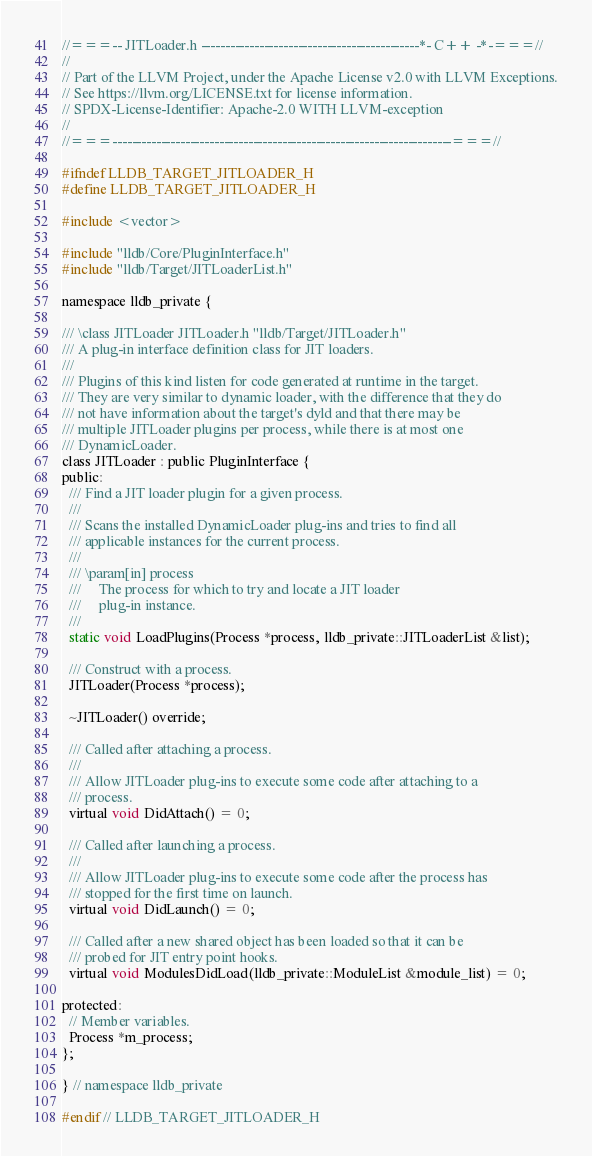<code> <loc_0><loc_0><loc_500><loc_500><_C_>//===-- JITLoader.h ---------------------------------------------*- C++ -*-===//
//
// Part of the LLVM Project, under the Apache License v2.0 with LLVM Exceptions.
// See https://llvm.org/LICENSE.txt for license information.
// SPDX-License-Identifier: Apache-2.0 WITH LLVM-exception
//
//===----------------------------------------------------------------------===//

#ifndef LLDB_TARGET_JITLOADER_H
#define LLDB_TARGET_JITLOADER_H

#include <vector>

#include "lldb/Core/PluginInterface.h"
#include "lldb/Target/JITLoaderList.h"

namespace lldb_private {

/// \class JITLoader JITLoader.h "lldb/Target/JITLoader.h"
/// A plug-in interface definition class for JIT loaders.
///
/// Plugins of this kind listen for code generated at runtime in the target.
/// They are very similar to dynamic loader, with the difference that they do
/// not have information about the target's dyld and that there may be
/// multiple JITLoader plugins per process, while there is at most one
/// DynamicLoader.
class JITLoader : public PluginInterface {
public:
  /// Find a JIT loader plugin for a given process.
  ///
  /// Scans the installed DynamicLoader plug-ins and tries to find all
  /// applicable instances for the current process.
  ///
  /// \param[in] process
  ///     The process for which to try and locate a JIT loader
  ///     plug-in instance.
  ///
  static void LoadPlugins(Process *process, lldb_private::JITLoaderList &list);

  /// Construct with a process.
  JITLoader(Process *process);

  ~JITLoader() override;

  /// Called after attaching a process.
  ///
  /// Allow JITLoader plug-ins to execute some code after attaching to a
  /// process.
  virtual void DidAttach() = 0;

  /// Called after launching a process.
  ///
  /// Allow JITLoader plug-ins to execute some code after the process has
  /// stopped for the first time on launch.
  virtual void DidLaunch() = 0;

  /// Called after a new shared object has been loaded so that it can be
  /// probed for JIT entry point hooks.
  virtual void ModulesDidLoad(lldb_private::ModuleList &module_list) = 0;

protected:
  // Member variables.
  Process *m_process;
};

} // namespace lldb_private

#endif // LLDB_TARGET_JITLOADER_H
</code> 